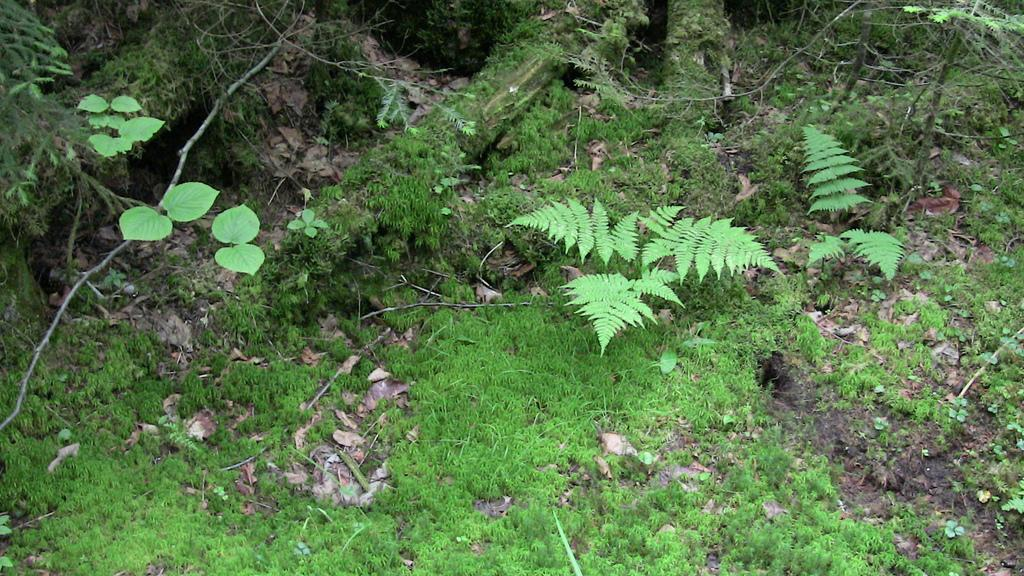What type of vegetation can be seen in the image? Dry leaves, grass, and plants are visible in the image. Can you describe the ground in the image? The ground is covered with grass and dry leaves. Are there any plants present in the image? Yes, there are plants in the image. What type of ornament is hanging from the tree in the image? There is no tree or ornament present in the image; it only features dry leaves, grass, and plants. Can you tell me how many rings are visible on the plants in the image? There are no rings visible on the plants in the image. 